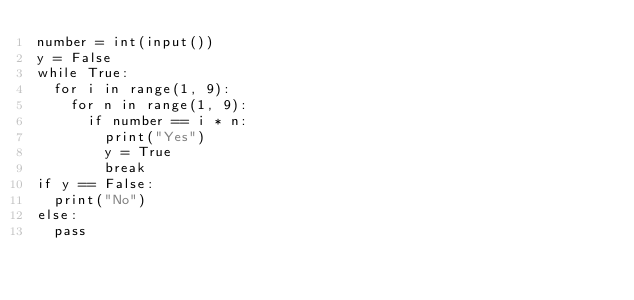Convert code to text. <code><loc_0><loc_0><loc_500><loc_500><_Python_>number = int(input())
y = False
while True:
  for i in range(1, 9):
    for n in range(1, 9):
      if number == i * n:
        print("Yes")
        y = True
        break
if y == False:
  print("No")
else:
  pass
</code> 